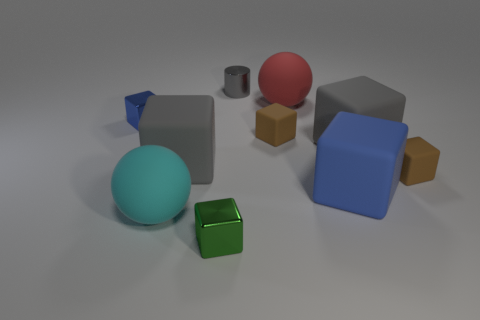Subtract all blue metal blocks. How many blocks are left? 6 Subtract all cyan spheres. How many spheres are left? 1 Subtract all spheres. How many objects are left? 8 Subtract all cyan balls. How many brown cubes are left? 2 Add 6 blue metallic blocks. How many blue metallic blocks are left? 7 Add 8 tiny gray metal cylinders. How many tiny gray metal cylinders exist? 9 Subtract 1 cyan spheres. How many objects are left? 9 Subtract 1 cylinders. How many cylinders are left? 0 Subtract all brown blocks. Subtract all red balls. How many blocks are left? 5 Subtract all large cyan matte things. Subtract all gray blocks. How many objects are left? 7 